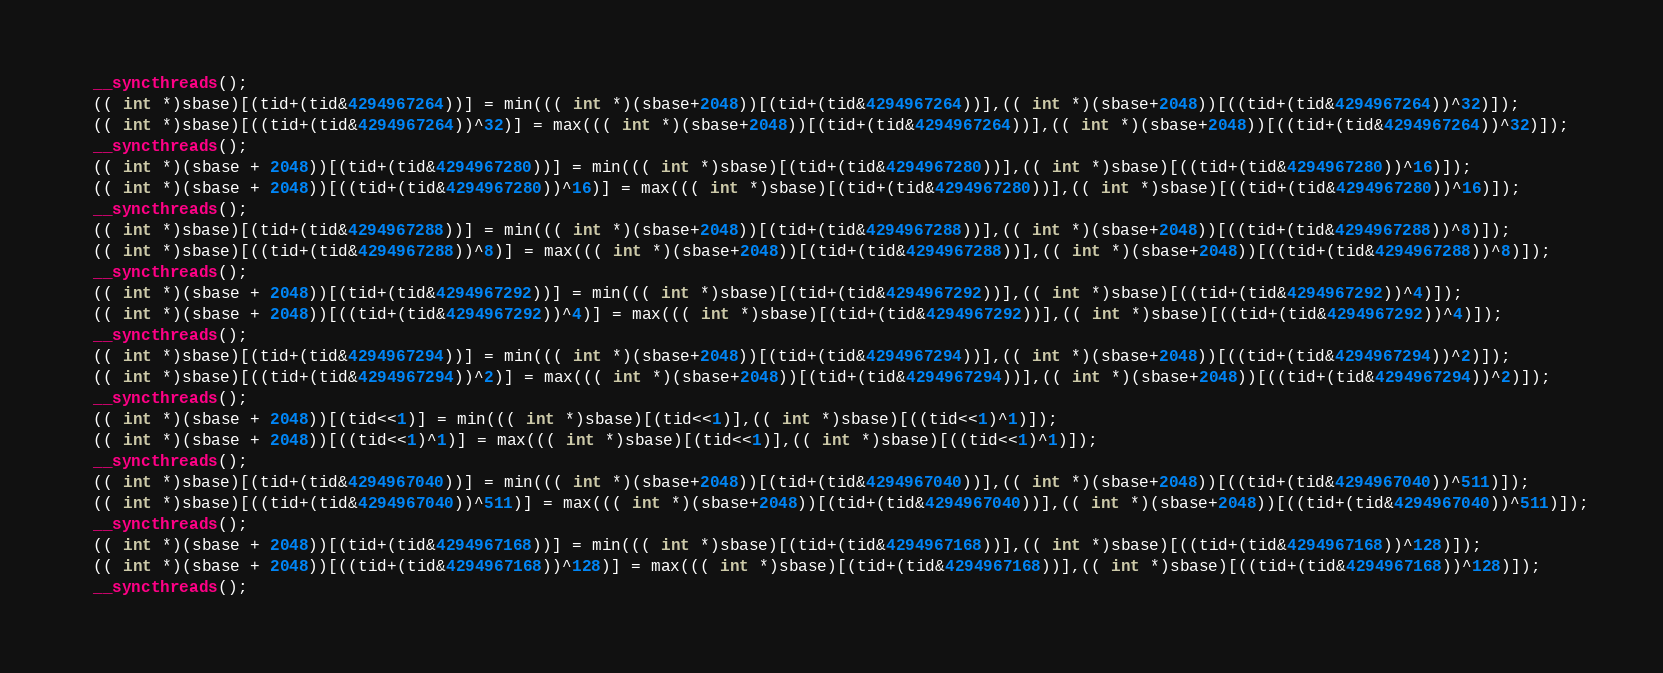Convert code to text. <code><loc_0><loc_0><loc_500><loc_500><_Cuda_>  __syncthreads();
  (( int *)sbase)[(tid+(tid&4294967264))] = min((( int *)(sbase+2048))[(tid+(tid&4294967264))],(( int *)(sbase+2048))[((tid+(tid&4294967264))^32)]);
  (( int *)sbase)[((tid+(tid&4294967264))^32)] = max((( int *)(sbase+2048))[(tid+(tid&4294967264))],(( int *)(sbase+2048))[((tid+(tid&4294967264))^32)]);
  __syncthreads();
  (( int *)(sbase + 2048))[(tid+(tid&4294967280))] = min((( int *)sbase)[(tid+(tid&4294967280))],(( int *)sbase)[((tid+(tid&4294967280))^16)]);
  (( int *)(sbase + 2048))[((tid+(tid&4294967280))^16)] = max((( int *)sbase)[(tid+(tid&4294967280))],(( int *)sbase)[((tid+(tid&4294967280))^16)]);
  __syncthreads();
  (( int *)sbase)[(tid+(tid&4294967288))] = min((( int *)(sbase+2048))[(tid+(tid&4294967288))],(( int *)(sbase+2048))[((tid+(tid&4294967288))^8)]);
  (( int *)sbase)[((tid+(tid&4294967288))^8)] = max((( int *)(sbase+2048))[(tid+(tid&4294967288))],(( int *)(sbase+2048))[((tid+(tid&4294967288))^8)]);
  __syncthreads();
  (( int *)(sbase + 2048))[(tid+(tid&4294967292))] = min((( int *)sbase)[(tid+(tid&4294967292))],(( int *)sbase)[((tid+(tid&4294967292))^4)]);
  (( int *)(sbase + 2048))[((tid+(tid&4294967292))^4)] = max((( int *)sbase)[(tid+(tid&4294967292))],(( int *)sbase)[((tid+(tid&4294967292))^4)]);
  __syncthreads();
  (( int *)sbase)[(tid+(tid&4294967294))] = min((( int *)(sbase+2048))[(tid+(tid&4294967294))],(( int *)(sbase+2048))[((tid+(tid&4294967294))^2)]);
  (( int *)sbase)[((tid+(tid&4294967294))^2)] = max((( int *)(sbase+2048))[(tid+(tid&4294967294))],(( int *)(sbase+2048))[((tid+(tid&4294967294))^2)]);
  __syncthreads();
  (( int *)(sbase + 2048))[(tid<<1)] = min((( int *)sbase)[(tid<<1)],(( int *)sbase)[((tid<<1)^1)]);
  (( int *)(sbase + 2048))[((tid<<1)^1)] = max((( int *)sbase)[(tid<<1)],(( int *)sbase)[((tid<<1)^1)]);
  __syncthreads();
  (( int *)sbase)[(tid+(tid&4294967040))] = min((( int *)(sbase+2048))[(tid+(tid&4294967040))],(( int *)(sbase+2048))[((tid+(tid&4294967040))^511)]);
  (( int *)sbase)[((tid+(tid&4294967040))^511)] = max((( int *)(sbase+2048))[(tid+(tid&4294967040))],(( int *)(sbase+2048))[((tid+(tid&4294967040))^511)]);
  __syncthreads();
  (( int *)(sbase + 2048))[(tid+(tid&4294967168))] = min((( int *)sbase)[(tid+(tid&4294967168))],(( int *)sbase)[((tid+(tid&4294967168))^128)]);
  (( int *)(sbase + 2048))[((tid+(tid&4294967168))^128)] = max((( int *)sbase)[(tid+(tid&4294967168))],(( int *)sbase)[((tid+(tid&4294967168))^128)]);
  __syncthreads();</code> 